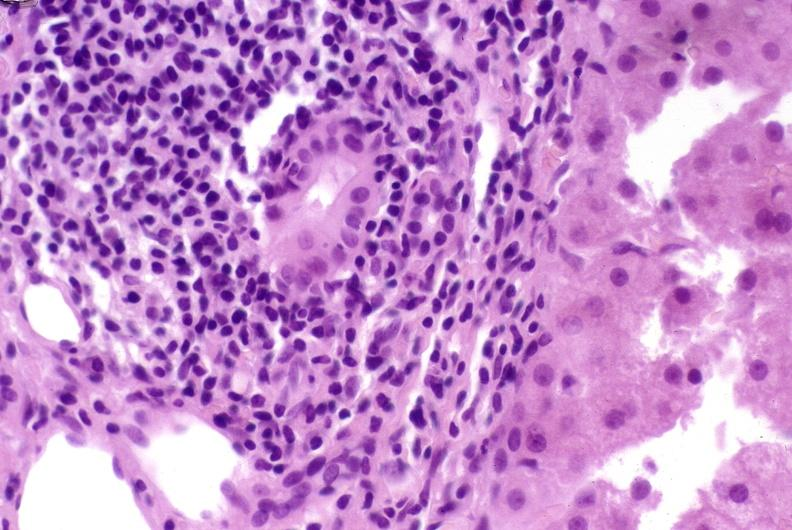s this myoma present?
Answer the question using a single word or phrase. No 